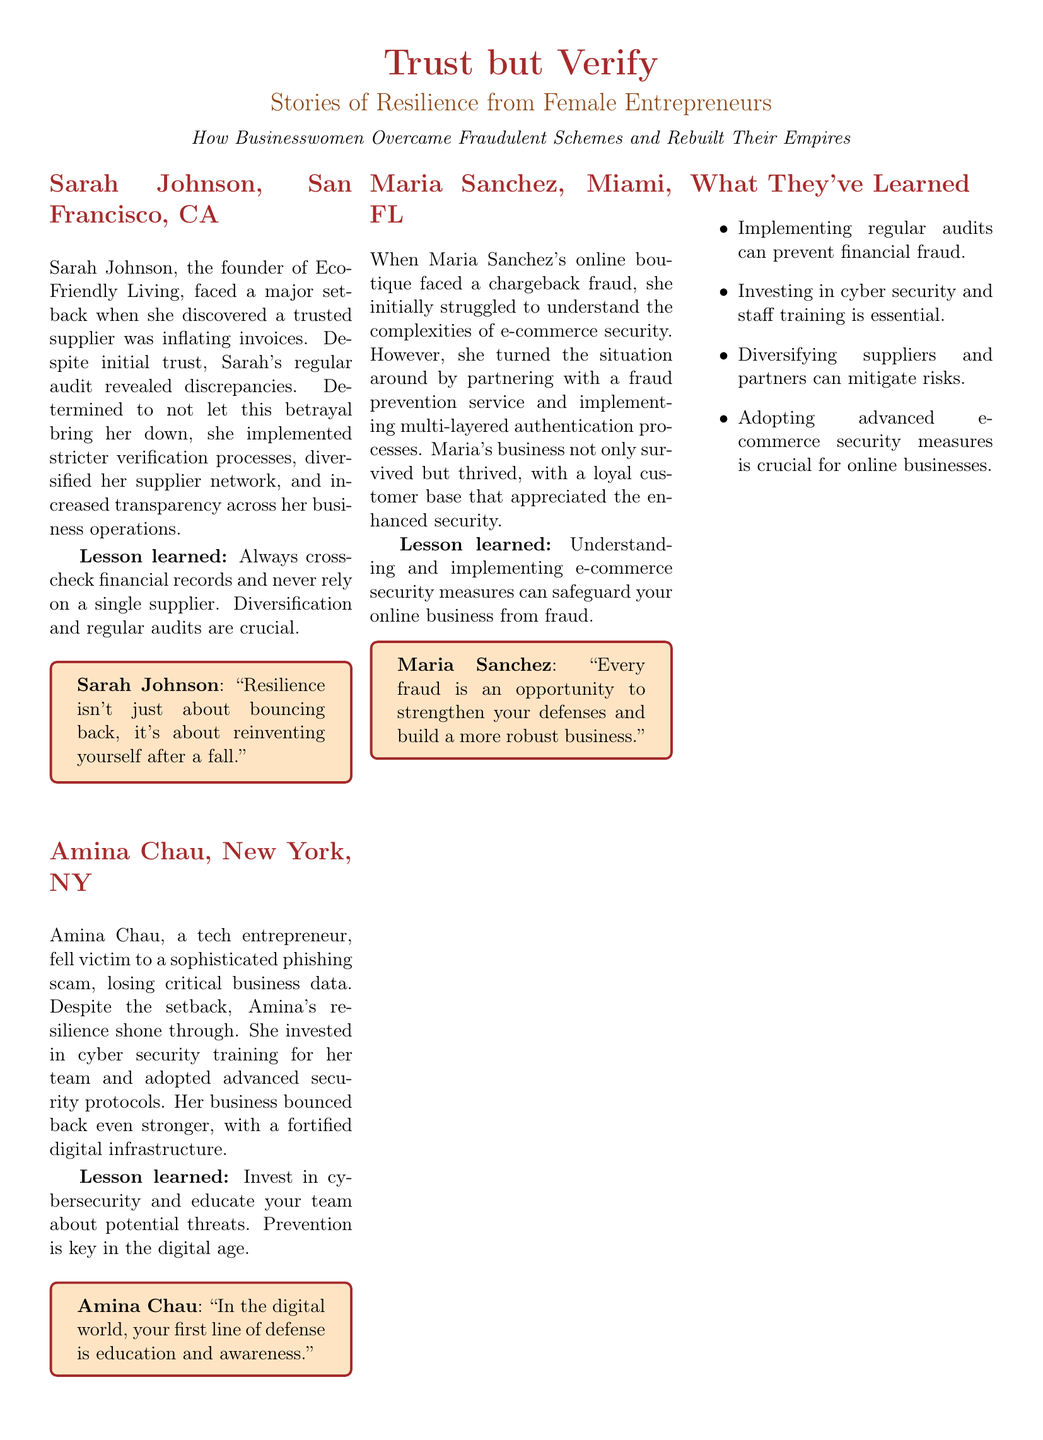What is the name of Sarah's company? The document states that Sarah Johnson is the founder of Eco-Friendly Living.
Answer: Eco-Friendly Living Where is Amina Chau based? The document mentions that Amina Chau's location is New York, NY.
Answer: New York, NY What did Maria Sanchez's boutique face? The document describes that Maria Sanchez's online boutique faced chargeback fraud.
Answer: Chargeback fraud What is a lesson learned by Amina Chau? The document highlights several lessons, one being to invest in cybersecurity and educate the team about potential threats.
Answer: Invest in cybersecurity What type of training did Amina provide to her team? The document indicates that Amina invested in cybersecurity training for her team.
Answer: Cybersecurity training Which entrepreneur mentioned multi-layered authentication? The document states that Maria Sanchez implemented multi-layered authentication processes.
Answer: Maria Sanchez How did Sarah Johnson respond to her supplier issue? According to the document, Sarah implemented stricter verification processes.
Answer: Stricter verification processes What is the main theme of the series? The document emphasizes stories of resilience from female entrepreneurs who have faced fraud.
Answer: Resilience from female entrepreneurs What can regular audits prevent? The document mentions that implementing regular audits can prevent financial fraud.
Answer: Financial fraud 